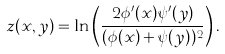Convert formula to latex. <formula><loc_0><loc_0><loc_500><loc_500>z ( x , y ) = \ln \left ( \frac { 2 \phi ^ { \prime } ( x ) \psi ^ { \prime } ( y ) } { ( \phi ( x ) + \psi ( y ) ) ^ { 2 } } \right ) .</formula> 